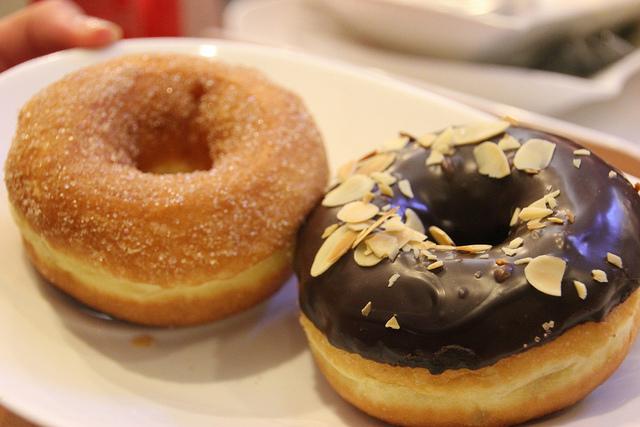What is the texture of the doughnut on the right?
Answer briefly. Chocolate. What flavor are the doughnuts?
Quick response, please. Chocolate and sugar. Is there almonds on the doughnut?
Quick response, please. Yes. 